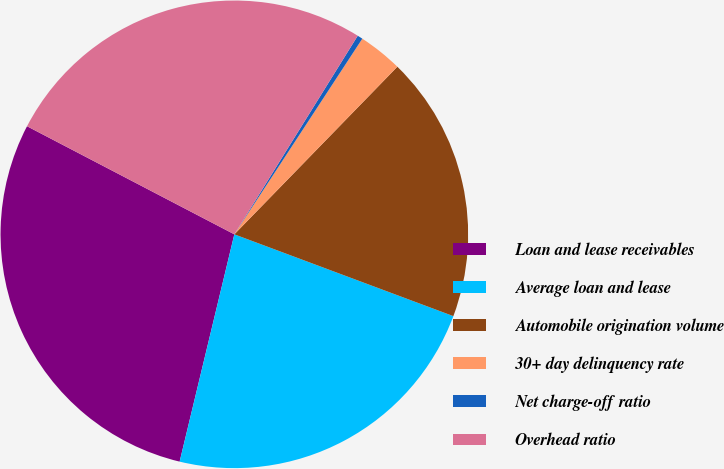Convert chart to OTSL. <chart><loc_0><loc_0><loc_500><loc_500><pie_chart><fcel>Loan and lease receivables<fcel>Average loan and lease<fcel>Automobile origination volume<fcel>30+ day delinquency rate<fcel>Net charge-off ratio<fcel>Overhead ratio<nl><fcel>28.89%<fcel>23.07%<fcel>18.41%<fcel>3.06%<fcel>0.37%<fcel>26.2%<nl></chart> 